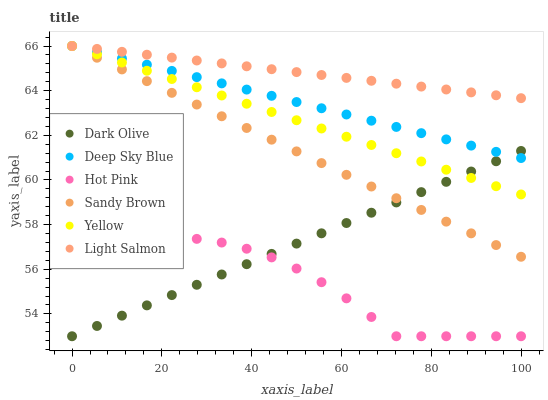Does Hot Pink have the minimum area under the curve?
Answer yes or no. Yes. Does Light Salmon have the maximum area under the curve?
Answer yes or no. Yes. Does Dark Olive have the minimum area under the curve?
Answer yes or no. No. Does Dark Olive have the maximum area under the curve?
Answer yes or no. No. Is Light Salmon the smoothest?
Answer yes or no. Yes. Is Hot Pink the roughest?
Answer yes or no. Yes. Is Dark Olive the smoothest?
Answer yes or no. No. Is Dark Olive the roughest?
Answer yes or no. No. Does Hot Pink have the lowest value?
Answer yes or no. Yes. Does Yellow have the lowest value?
Answer yes or no. No. Does Sandy Brown have the highest value?
Answer yes or no. Yes. Does Dark Olive have the highest value?
Answer yes or no. No. Is Dark Olive less than Light Salmon?
Answer yes or no. Yes. Is Light Salmon greater than Dark Olive?
Answer yes or no. Yes. Does Sandy Brown intersect Yellow?
Answer yes or no. Yes. Is Sandy Brown less than Yellow?
Answer yes or no. No. Is Sandy Brown greater than Yellow?
Answer yes or no. No. Does Dark Olive intersect Light Salmon?
Answer yes or no. No. 